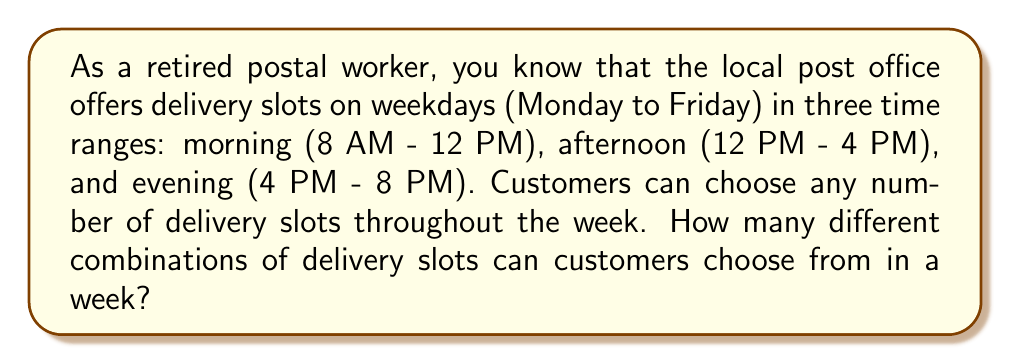Could you help me with this problem? Let's approach this step-by-step:

1) First, we need to determine the total number of available slots in a week:
   - There are 5 weekdays
   - Each day has 3 time slots
   - So, there are $5 \times 3 = 15$ total slots in a week

2) Now, for each slot, a customer has two choices:
   - Choose the slot
   - Don't choose the slot

3) This is a perfect scenario for using the multiplication principle of counting. For each slot, we have 2 choices, and we have 15 slots in total.

4) The total number of combinations is therefore:

   $$ 2^{15} $$

5) This is because for each slot, we multiply by 2 (the number of choices for that slot), and we do this 15 times (once for each slot).

6) Calculating this:

   $$ 2^{15} = 32,768 $$

This includes all possibilities, from choosing no slots at all (1 combination) to choosing all 15 slots (1 combination), and everything in between.
Answer: There are $2^{15} = 32,768$ different combinations of delivery slots that customers can choose from in a week. 